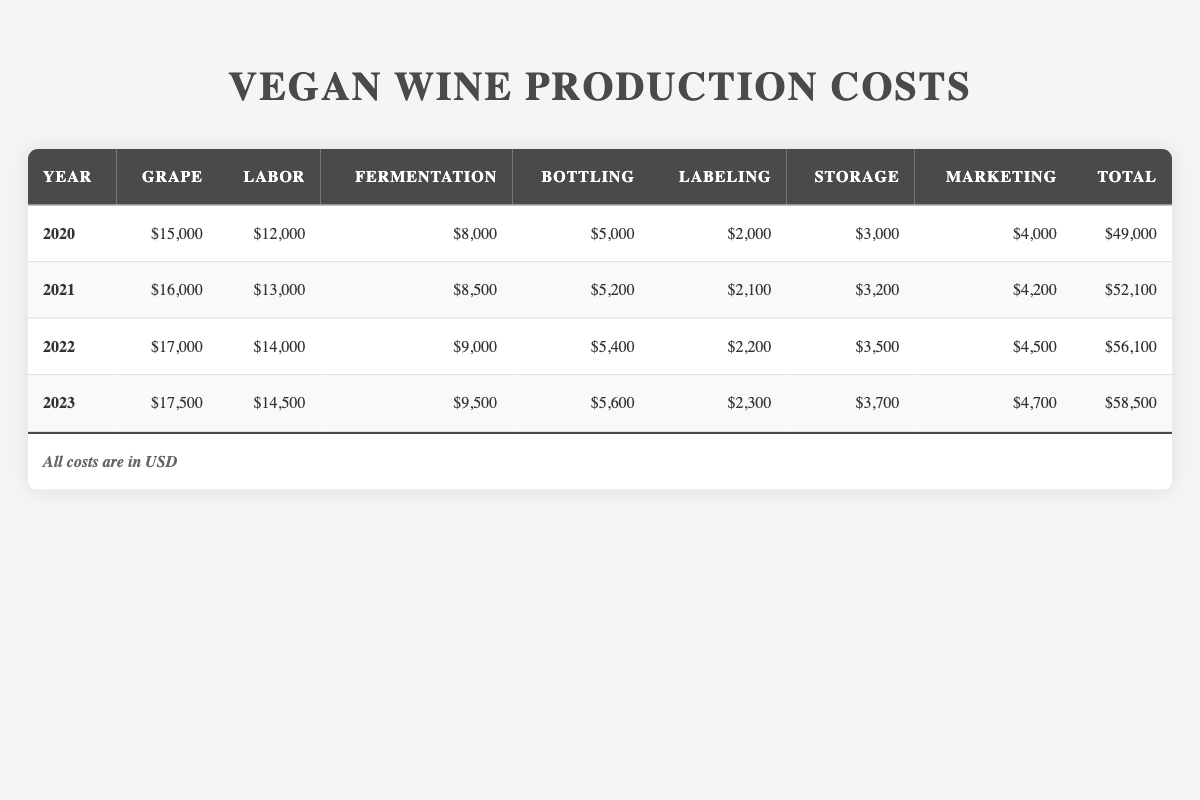What was the total production cost for vegan wines in 2021? In 2021, the total production cost is listed directly in the table as $52,100.
Answer: $52,100 Which year's grape cost was the highest? By comparing the grape costs for each year, $17,500 in 2023 is the highest, while the 2020 grape cost is $15,000, 2021 is $16,000, and 2022 is $17,000.
Answer: 2023 How much did the labor cost increase from 2020 to 2023? The labor cost in 2020 was $12,000 and increased to $14,500 in 2023. The difference is $14,500 - $12,000 = $2,500.
Answer: $2,500 What is the average bottling cost over the four years? The bottling costs are $5,000 (2020), $5,200 (2021), $5,400 (2022), and $5,600 (2023). The sum is $5,000 + $5,200 + $5,400 + $5,600 = $21,200. Dividing this by 4 gives an average of $21,200 ÷ 4 = $5,300.
Answer: $5,300 Was the marketing cost consistent across the years? By looking at the marketing costs, $4,000 (2020), $4,200 (2021), $4,500 (2022), and $4,700 (2023), it shows an increase each year, indicating inconsistency.
Answer: No Which cost category had the smallest amount in 2022? In 2022, the labeling cost was $2,200, which is less than all other costs listed for that year.
Answer: Labeling cost What was the total cost increase from 2020 to 2023? The total cost in 2020 is $49,000 and in 2023 it is $58,500. The difference is $58,500 - $49,000 = $9,500.
Answer: $9,500 How does the fermentation cost in 2021 compare to that in 2022? The fermentation cost in 2021 was $8,500 and increased to $9,000 in 2022. Thus, fermentation cost rose by $9,000 - $8,500 = $500.
Answer: Increased by $500 